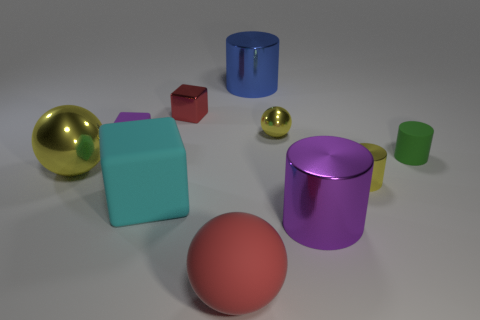Does the small cube right of the small purple rubber object have the same color as the small sphere?
Ensure brevity in your answer.  No. There is a big metallic thing that is on the right side of the large shiny cylinder that is behind the big purple object; what is its shape?
Make the answer very short. Cylinder. How many things are objects on the left side of the large red object or matte objects that are left of the large blue cylinder?
Ensure brevity in your answer.  5. There is a red thing that is made of the same material as the purple cylinder; what is its shape?
Your answer should be compact. Cube. Is there any other thing that is the same color as the matte cylinder?
Your answer should be compact. No. There is a small yellow object that is the same shape as the green thing; what material is it?
Provide a succinct answer. Metal. How many other objects are the same size as the red metal thing?
Your answer should be compact. 4. What is the material of the blue cylinder?
Provide a short and direct response. Metal. Are there more tiny yellow objects that are in front of the big yellow metallic thing than big cyan metal spheres?
Your response must be concise. Yes. Are there any yellow spheres?
Provide a short and direct response. Yes. 